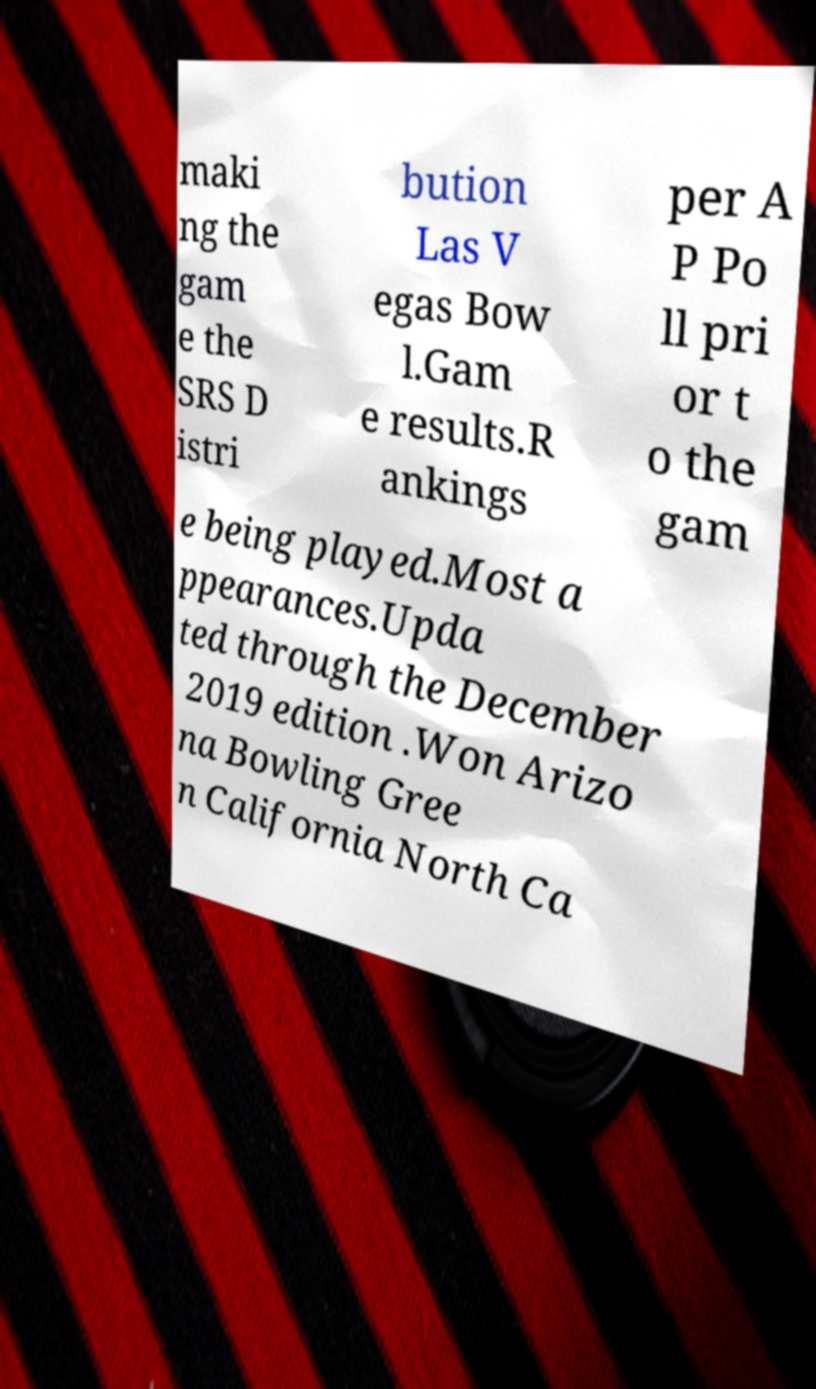Please identify and transcribe the text found in this image. maki ng the gam e the SRS D istri bution Las V egas Bow l.Gam e results.R ankings per A P Po ll pri or t o the gam e being played.Most a ppearances.Upda ted through the December 2019 edition .Won Arizo na Bowling Gree n California North Ca 